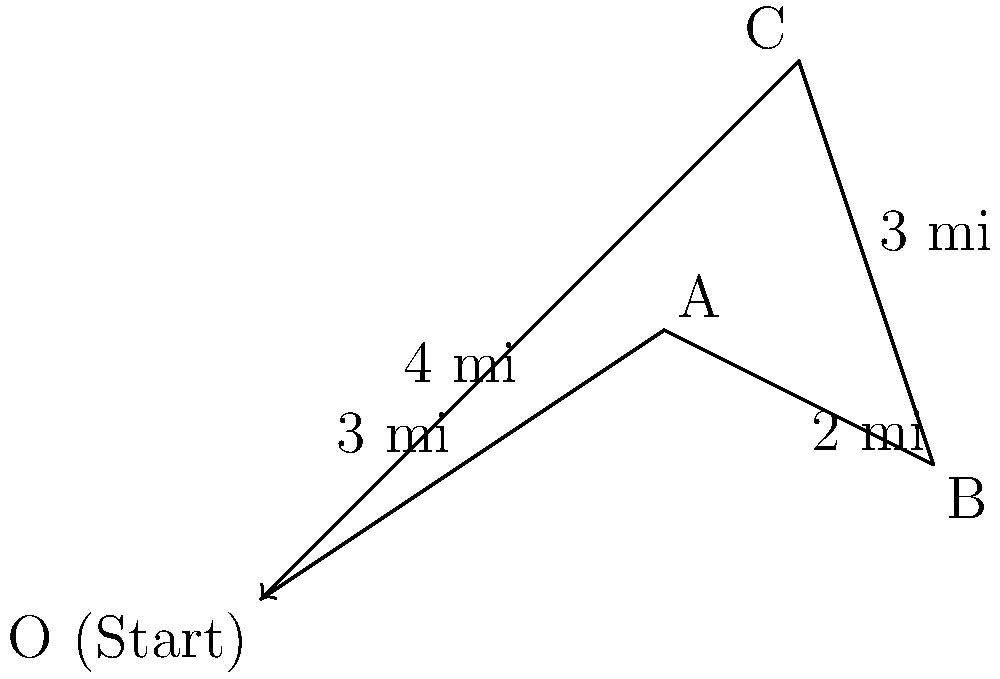As a conservative-themed product distributor, you need to optimize your shipping route. Your delivery truck starts at point O and must visit points A, B, and C before returning to O. Given the vector path $\vec{OA} = 3\hat{i} + 2\hat{j}$, $\vec{AB} = 2\hat{i} - \hat{j}$, and $\vec{BC} = -\hat{i} + 3\hat{j}$, calculate the total distance traveled in miles. To find the total distance traveled, we need to:
1. Calculate the magnitude of each vector (leg of the journey)
2. Add the magnitudes together, including the return trip from C to O

Step 1: Calculate magnitudes
a) $|\vec{OA}| = \sqrt{3^2 + 2^2} = \sqrt{13} \approx 3.61$ miles
b) $|\vec{AB}| = \sqrt{2^2 + (-1)^2} = \sqrt{5} \approx 2.24$ miles
c) $|\vec{BC}| = \sqrt{(-1)^2 + 3^2} = \sqrt{10} \approx 3.16$ miles
d) For $\vec{CO}$, we can use vector addition:
   $\vec{CO} = -(\vec{OA} + \vec{AB} + \vec{BC})$
   $\vec{CO} = -(3\hat{i} + 2\hat{j} + 2\hat{i} - \hat{j} - \hat{i} + 3\hat{j})$
   $\vec{CO} = -(4\hat{i} + 4\hat{j}) = -4\hat{i} - 4\hat{j}$
   $|\vec{CO}| = \sqrt{(-4)^2 + (-4)^2} = \sqrt{32} = 4\sqrt{2} \approx 5.66$ miles

Step 2: Add all magnitudes
Total distance = $|\vec{OA}| + |\vec{AB}| + |\vec{BC}| + |\vec{CO}|$
$\approx 3.61 + 2.24 + 3.16 + 5.66 = 14.67$ miles
Answer: 14.67 miles 